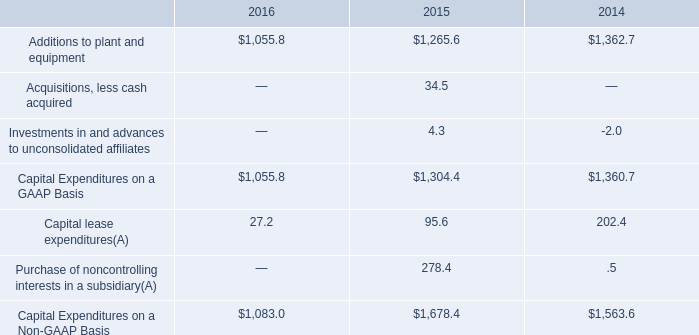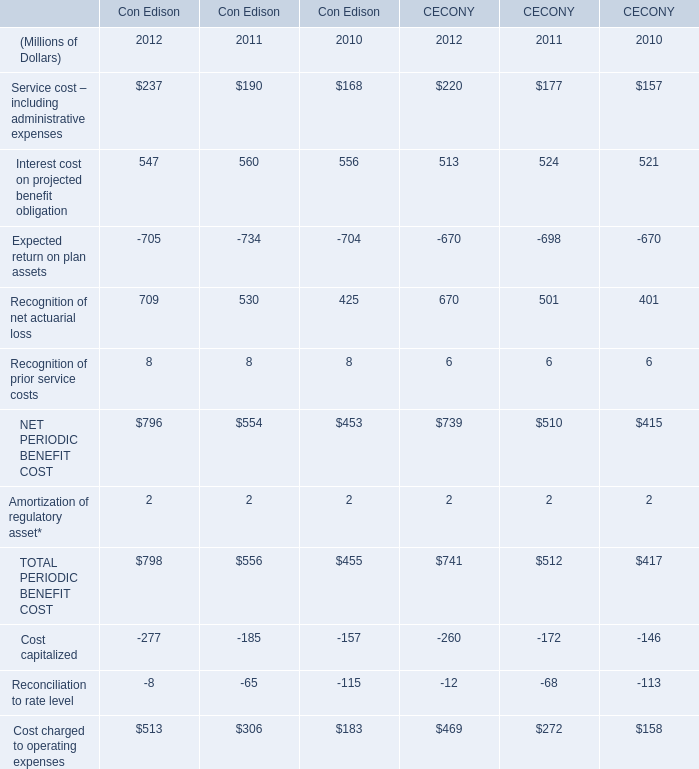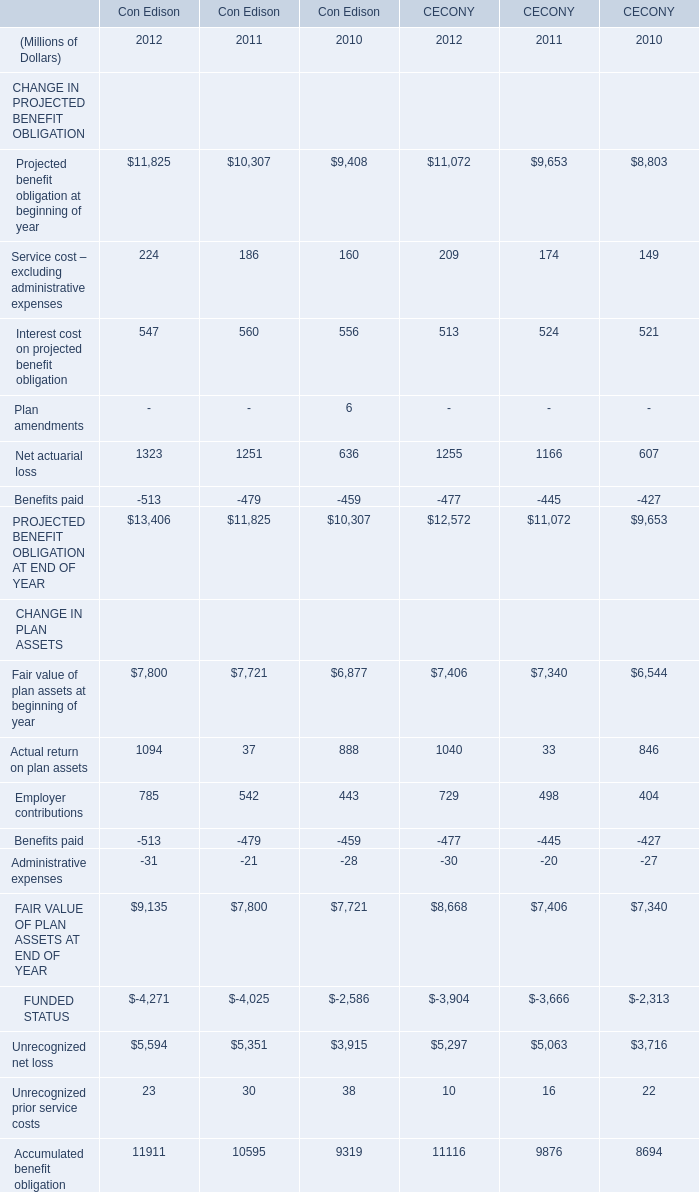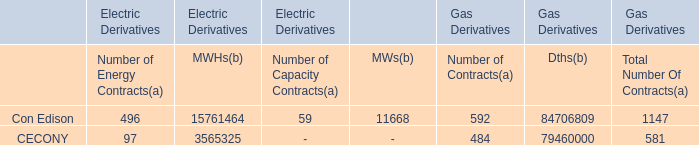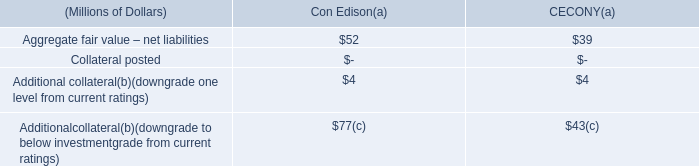What is the sum of Con Edison PERIODIC BENEFIT COST in 2012 ? (in million) 
Computations: (796 + 2)
Answer: 798.0. 